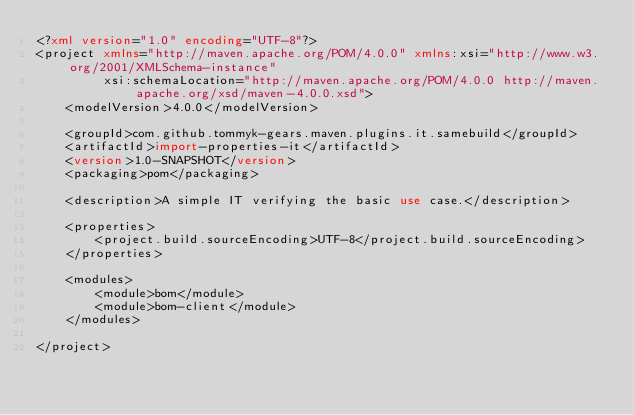<code> <loc_0><loc_0><loc_500><loc_500><_XML_><?xml version="1.0" encoding="UTF-8"?>
<project xmlns="http://maven.apache.org/POM/4.0.0" xmlns:xsi="http://www.w3.org/2001/XMLSchema-instance"
         xsi:schemaLocation="http://maven.apache.org/POM/4.0.0 http://maven.apache.org/xsd/maven-4.0.0.xsd">
    <modelVersion>4.0.0</modelVersion>

    <groupId>com.github.tommyk-gears.maven.plugins.it.samebuild</groupId>
    <artifactId>import-properties-it</artifactId>
    <version>1.0-SNAPSHOT</version>
    <packaging>pom</packaging>

    <description>A simple IT verifying the basic use case.</description>

    <properties>
        <project.build.sourceEncoding>UTF-8</project.build.sourceEncoding>
    </properties>

    <modules>
        <module>bom</module>
        <module>bom-client</module>
    </modules>

</project>
</code> 